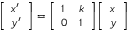Convert formula to latex. <formula><loc_0><loc_0><loc_500><loc_500>{ \left [ \begin{array} { l } { x ^ { \prime } } \\ { y ^ { \prime } } \end{array} \right ] } = { \left [ \begin{array} { l l } { 1 } & { k } \\ { 0 } & { 1 } \end{array} \right ] } { \left [ \begin{array} { l } { x } \\ { y } \end{array} \right ] }</formula> 